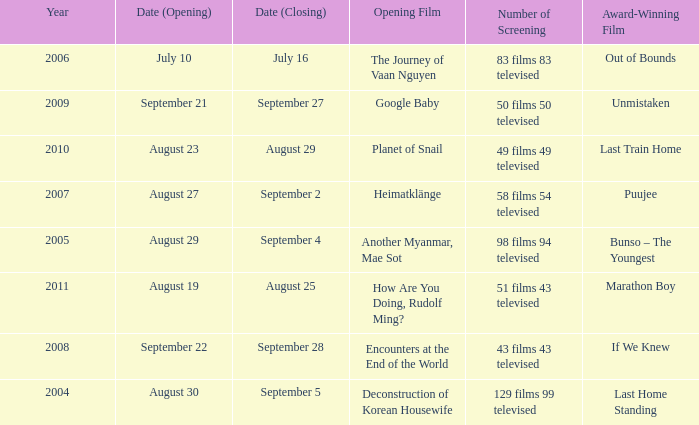Which award-winning film has a closing date of September 4? Bunso – The Youngest. 